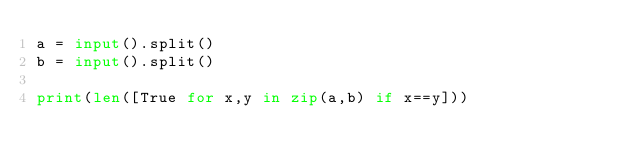Convert code to text. <code><loc_0><loc_0><loc_500><loc_500><_Python_>a = input().split()
b = input().split()

print(len([True for x,y in zip(a,b) if x==y]))</code> 